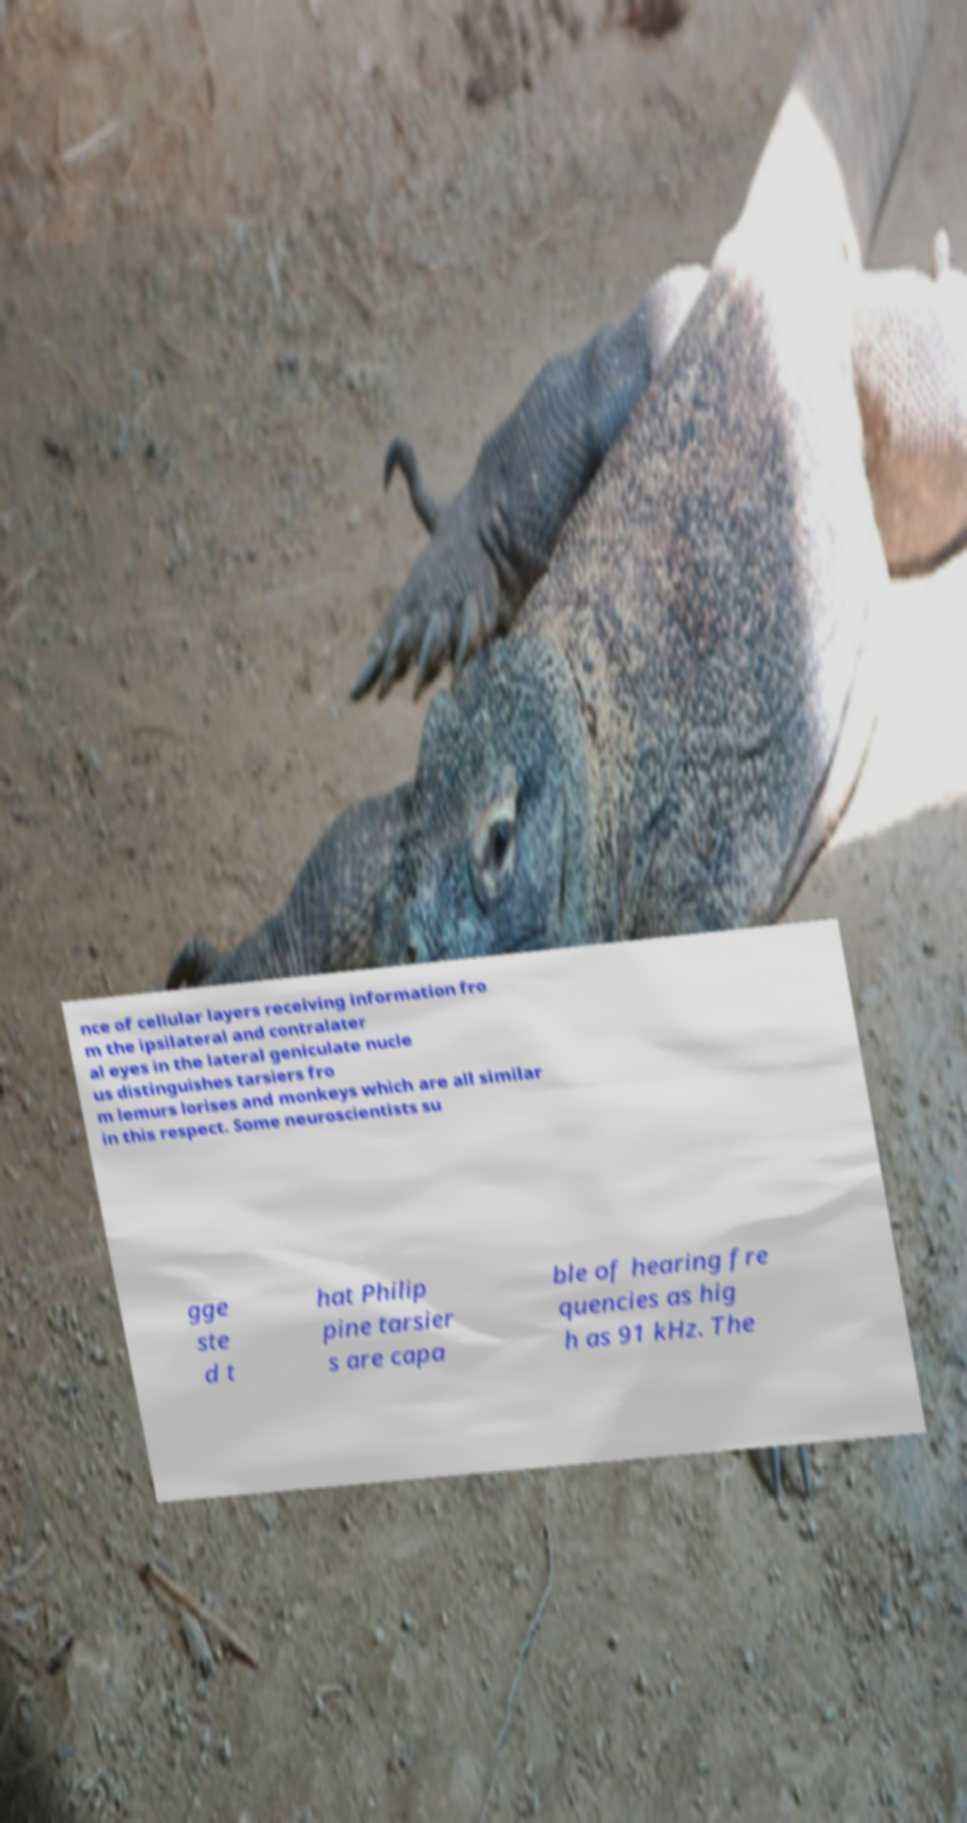What messages or text are displayed in this image? I need them in a readable, typed format. nce of cellular layers receiving information fro m the ipsilateral and contralater al eyes in the lateral geniculate nucle us distinguishes tarsiers fro m lemurs lorises and monkeys which are all similar in this respect. Some neuroscientists su gge ste d t hat Philip pine tarsier s are capa ble of hearing fre quencies as hig h as 91 kHz. The 